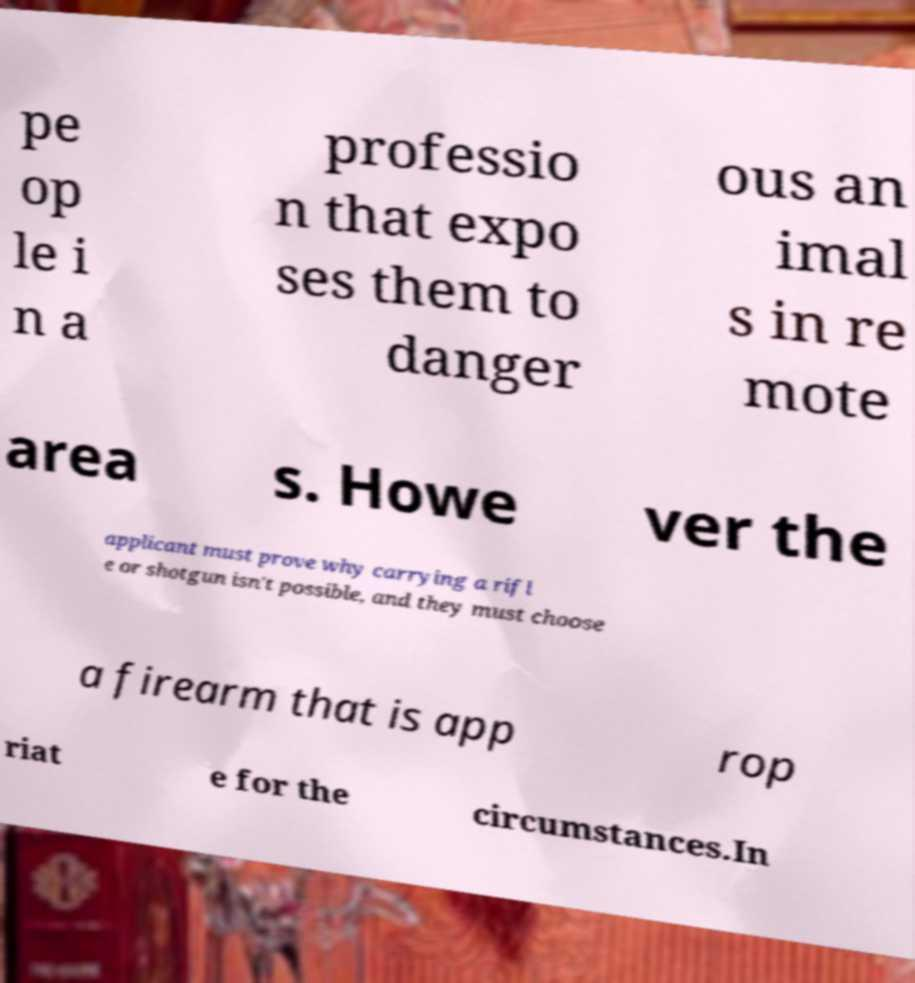Please identify and transcribe the text found in this image. pe op le i n a professio n that expo ses them to danger ous an imal s in re mote area s. Howe ver the applicant must prove why carrying a rifl e or shotgun isn't possible, and they must choose a firearm that is app rop riat e for the circumstances.In 